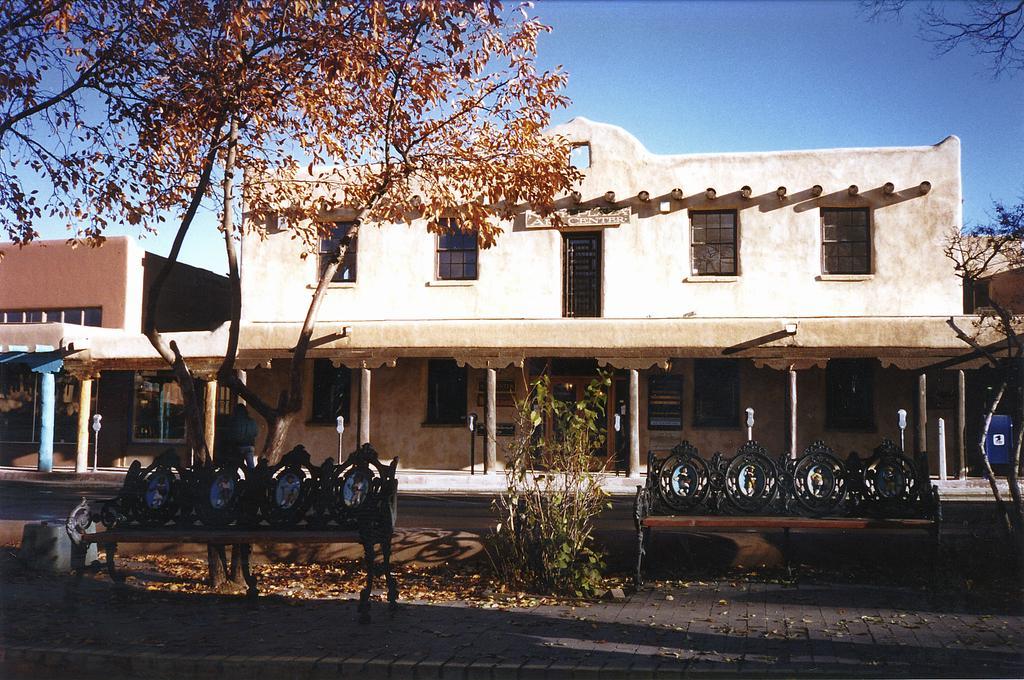How would you summarize this image in a sentence or two? In this image we can see some buildings with windows and the pillars. We can also see some poles, benches, plants, trees, some dried leaves on the ground and the sky which looks cloudy. 